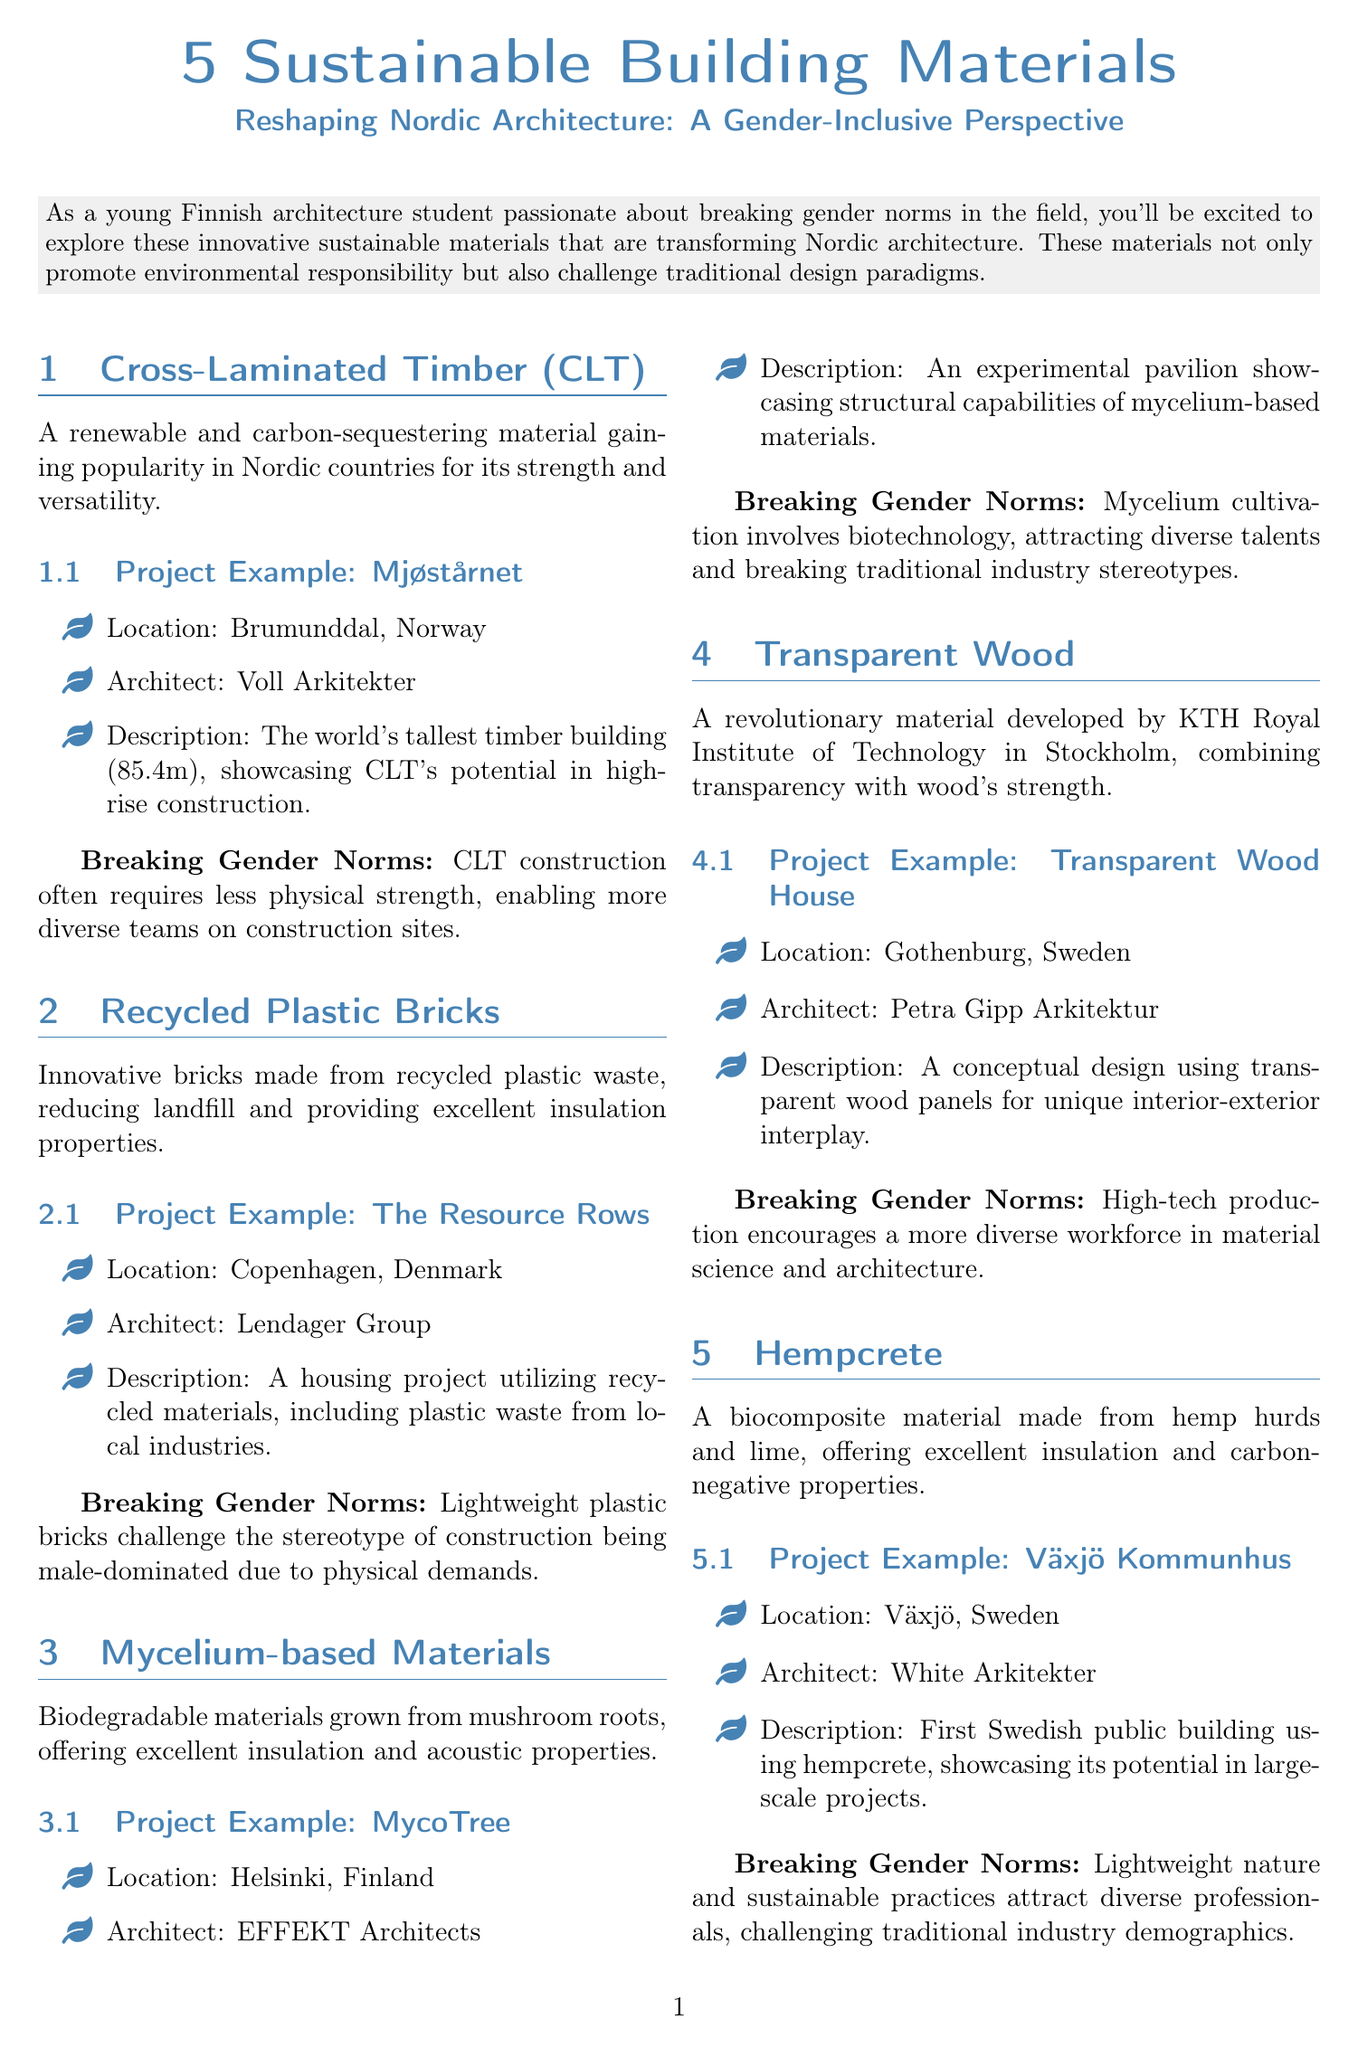What is the title of the document? The title of the document is presented at the top and summarizes the topic: sustainable building materials in Nordic architecture.
Answer: 5 Sustainable Building Materials Reshaping Nordic Architecture: A Gender-Inclusive Perspective How tall is the Mjøstårnet building? The document mentions that Mjøstårnet is the world's tallest timber building, giving its height explicitly.
Answer: 85.4 meters Which architect designed the Transparent Wood House? Information about the architect associated with a specific project is clearly stated in the project examples.
Answer: Petra Gipp Arkitektur What material is used in the Växjö Kommunhus? The document specifies the construction material used in this public building project.
Answer: Hempcrete How does CLT affect team diversity on construction sites? The document includes explanations of how each material contributes to breaking gender norms, particularly in construction.
Answer: Requires less physical strength What was innovative about the Resource Rows project? This question prompts reasoning about the use of materials and their environmental impact as discussed in the document.
Answer: Utilizes recycled materials What unique property does mycelium-based material offer? This aspect focuses on the characteristics of the materials mentioned in the document, specifically mycelium-based materials.
Answer: Excellent insulation and acoustic properties Which country is the MycoTree located in? According to the project examples, each material has a specified location for its associated project.
Answer: Finland What is the main goal of the newsletter? This question addresses the overall purpose of the document, which is highlighted in the introduction and conclusion.
Answer: Paving the way for a more inclusive and diverse field 